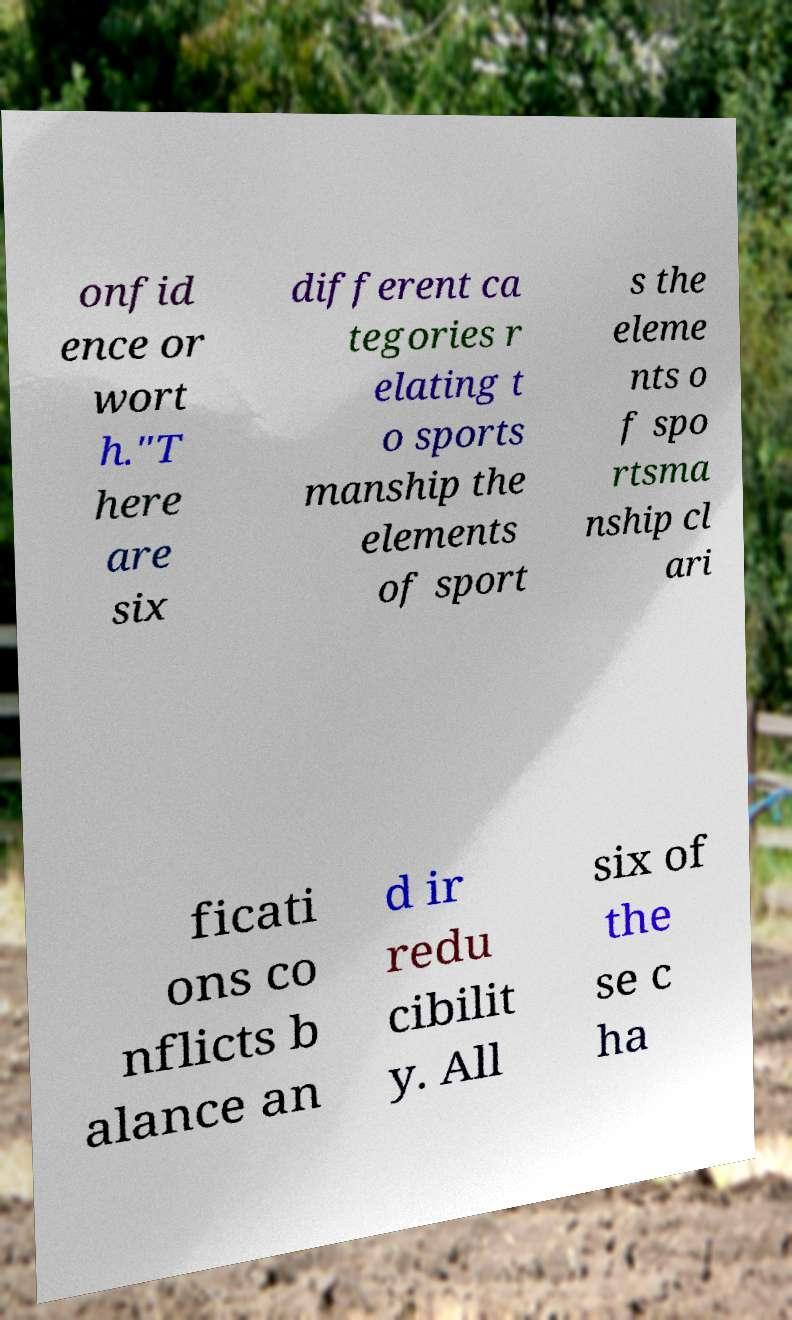Can you read and provide the text displayed in the image?This photo seems to have some interesting text. Can you extract and type it out for me? onfid ence or wort h."T here are six different ca tegories r elating t o sports manship the elements of sport s the eleme nts o f spo rtsma nship cl ari ficati ons co nflicts b alance an d ir redu cibilit y. All six of the se c ha 